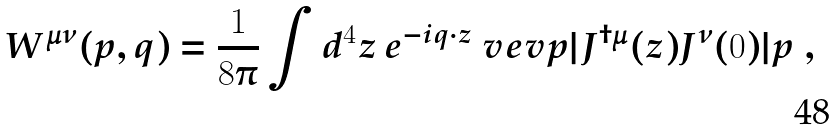Convert formula to latex. <formula><loc_0><loc_0><loc_500><loc_500>W ^ { \mu \nu } ( p , q ) & = \frac { 1 } { 8 \pi } \int d ^ { 4 } z \, e ^ { - i q \cdot z } \ v e v { p | J ^ { \dagger \mu } ( z ) J ^ { \nu } ( 0 ) | p } \ ,</formula> 